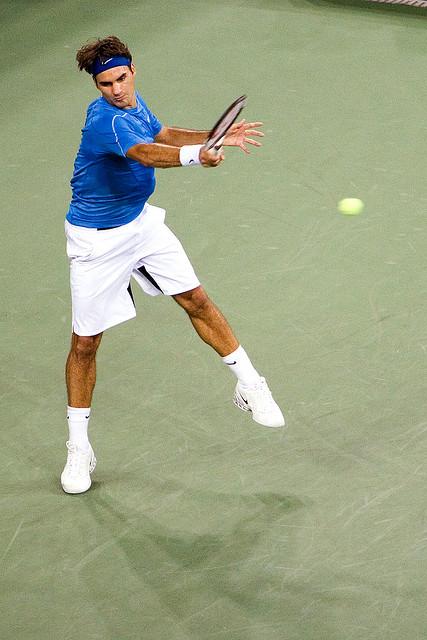What color is the ball?
Short answer required. Yellow. What is this person holding?
Be succinct. Racket. What direction is the man looking?
Give a very brief answer. Down. What color is his shirt?
Write a very short answer. Blue. What color are his shoes?
Be succinct. White. What are these man's emotions?
Answer briefly. Competitive. 